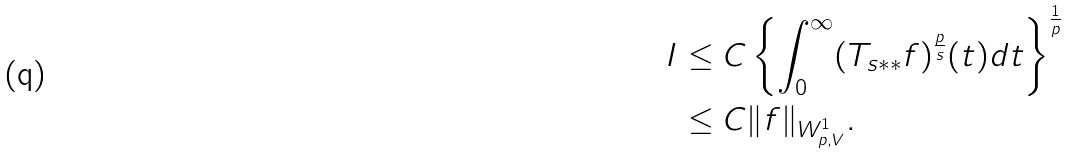Convert formula to latex. <formula><loc_0><loc_0><loc_500><loc_500>I & \leq C \left \{ \int _ { 0 } ^ { \infty } ( T _ { s * * } f ) ^ { \frac { p } { s } } ( t ) d t \right \} ^ { \frac { 1 } { p } } \\ & \leq C \| f \| _ { W _ { p , V } ^ { 1 } } .</formula> 